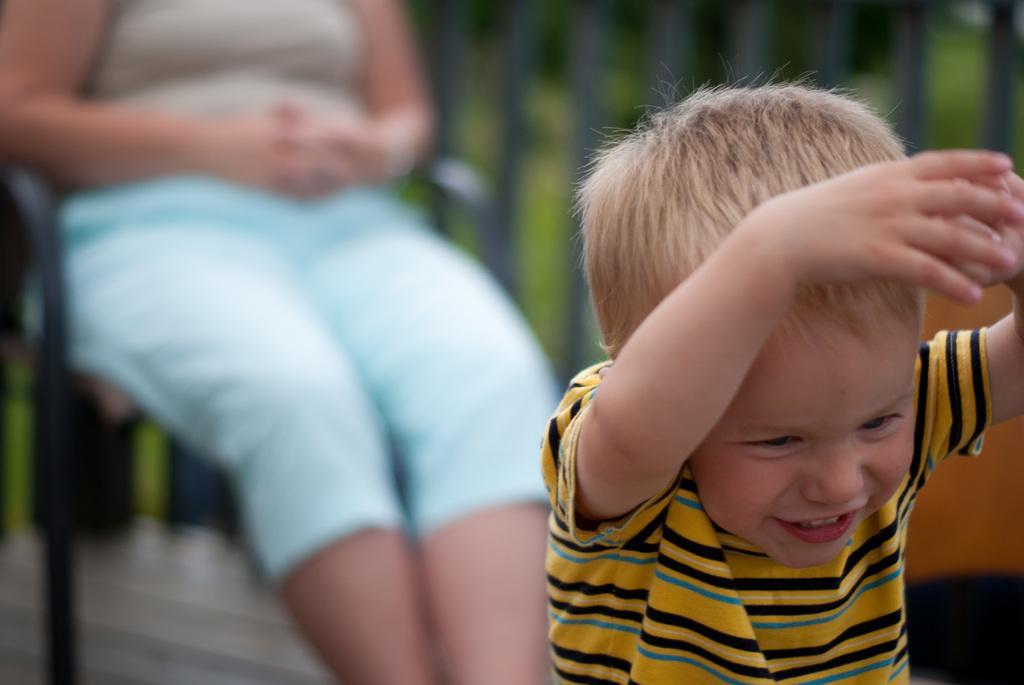Could you give a brief overview of what you see in this image? In this picture there is a small boy on the right side of the image and there is a lady who is sitting on the chair in the background area of the image. 